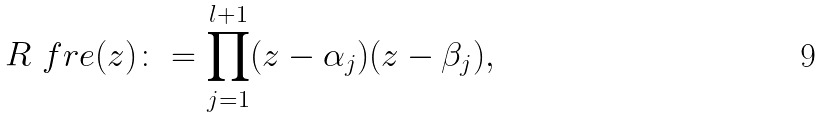Convert formula to latex. <formula><loc_0><loc_0><loc_500><loc_500>R _ { \ } f r e ( z ) \colon = \prod _ { j = 1 } ^ { l + 1 } ( z - \alpha _ { j } ) ( z - \beta _ { j } ) ,</formula> 